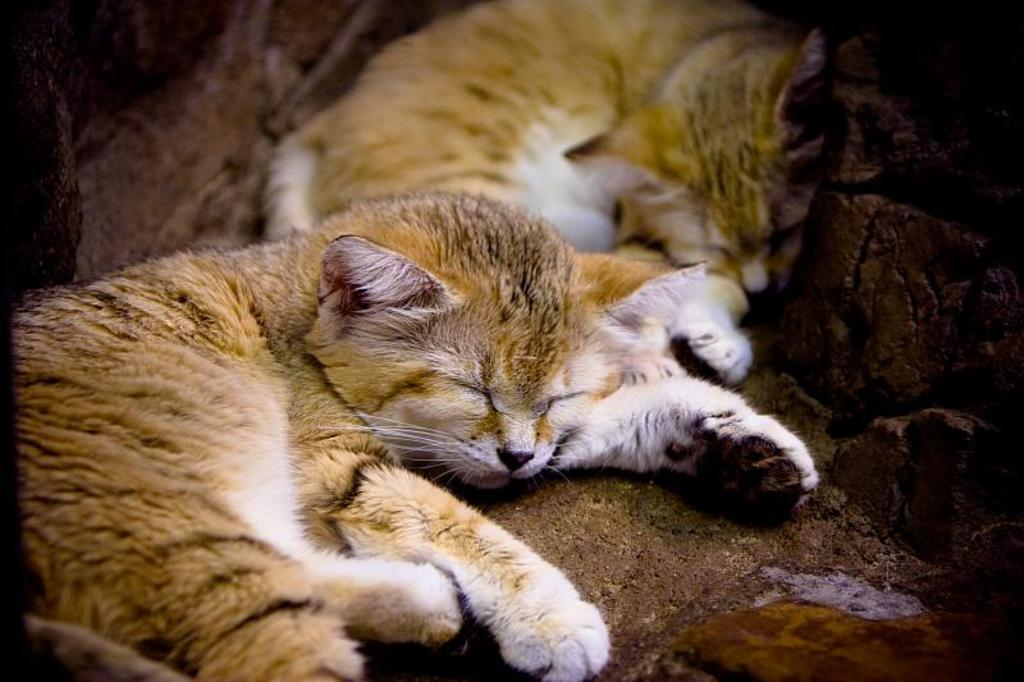How many cats are present in the image? There are two cats in the image. What are the cats doing in the image? The cats are sleeping. What color combination can be observed on the cats? The cats have a cream and white color combination. What type of feather can be seen on the cats in the image? There are no feathers present on the cats in the image; they are cats, not birds. 